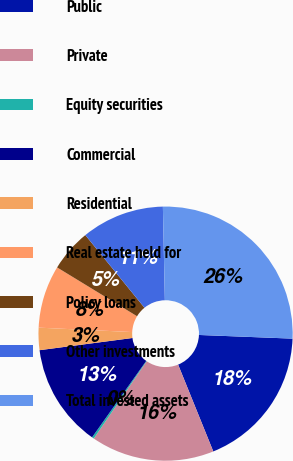Convert chart. <chart><loc_0><loc_0><loc_500><loc_500><pie_chart><fcel>Public<fcel>Private<fcel>Equity securities<fcel>Commercial<fcel>Residential<fcel>Real estate held for<fcel>Policy loans<fcel>Other investments<fcel>Total invested assets<nl><fcel>18.25%<fcel>15.68%<fcel>0.26%<fcel>13.11%<fcel>2.83%<fcel>7.97%<fcel>5.4%<fcel>10.54%<fcel>25.96%<nl></chart> 